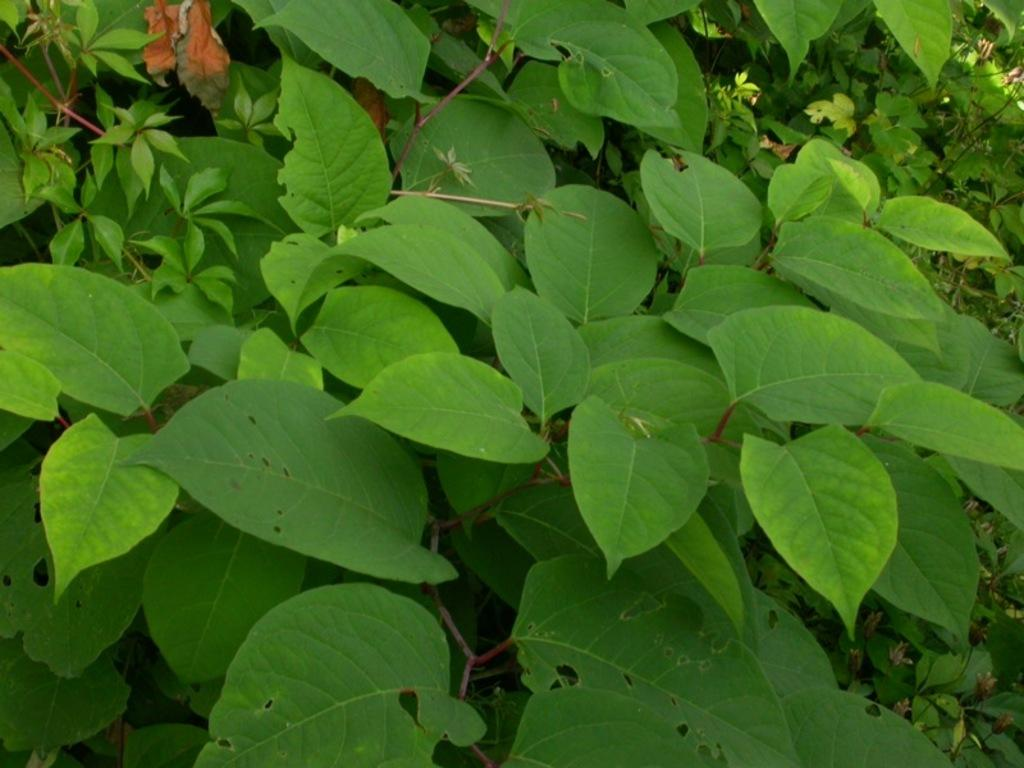What type of living organisms can be seen in the image? Plants can be seen in the image. What type of pigs can be seen playing during the meeting in the image? There is no meeting, pigs, or play depicted in the image; it only contains plants. 